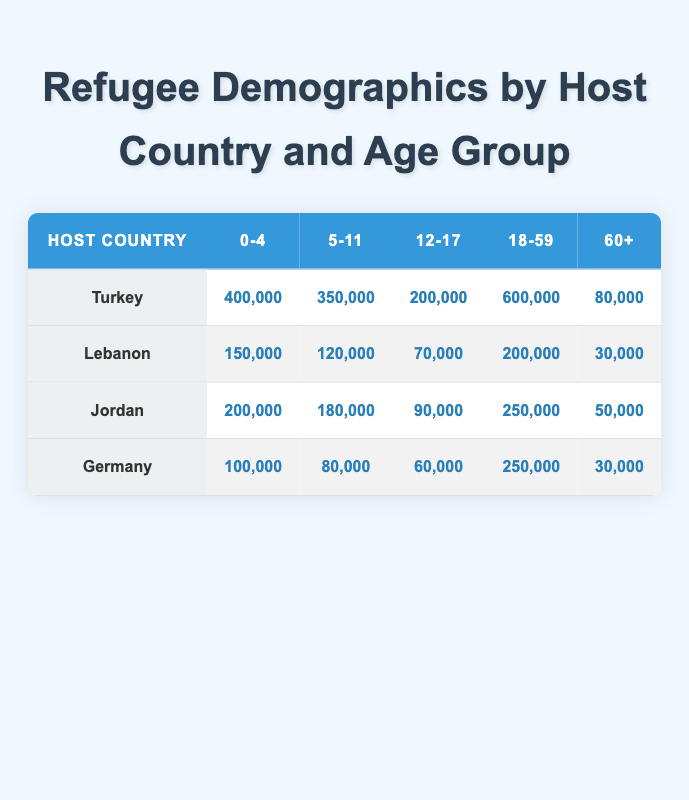What is the total number of refugees in Turkey? To find the total number of refugees in Turkey, I need to sum the counts across all age groups listed for Turkey: 400,000 (0-4) + 350,000 (5-11) + 200,000 (12-17) + 600,000 (18-59) + 80,000 (60+) = 1,630,000.
Answer: 1,630,000 Which age group has the highest number of refugees in Lebanon? The age group with the highest number of refugees in Lebanon can be determined by comparing the refugee counts: 150,000 (0-4), 120,000 (5-11), 70,000 (12-17), 200,000 (18-59), 30,000 (60+). The highest is 200,000 in the age group 18-59.
Answer: 18-59 Is the number of refugees aged 60+ in Jordan greater than those aged 12-17? For Jordan, the number of refugees aged 60+ is 50,000, while those aged 12-17 is 90,000. Since 50,000 is less than 90,000, the statement is false.
Answer: No What is the combined refugee count for age groups 0-4 and 5-11 in Germany? To find the combined count for age groups 0-4 and 5-11 in Germany, sum the two counts: 100,000 (0-4) + 80,000 (5-11) = 180,000.
Answer: 180,000 Which host country has the least number of refugees in the age group 60+? Looking at the counts for the age group 60+ across all host countries: Turkey has 80,000, Lebanon has 30,000, Jordan has 50,000, and Germany has 30,000. Both Lebanon and Germany have the least at 30,000.
Answer: Lebanon and Germany What is the average number of refugees aged 0-4 across all host countries? I need to calculate the average by summing the refugee counts for the age group 0-4: 400,000 (Turkey) + 150,000 (Lebanon) + 200,000 (Jordan) + 100,000 (Germany) = 850,000. Then, divide by the number of countries (4): 850,000 / 4 = 212,500.
Answer: 212,500 